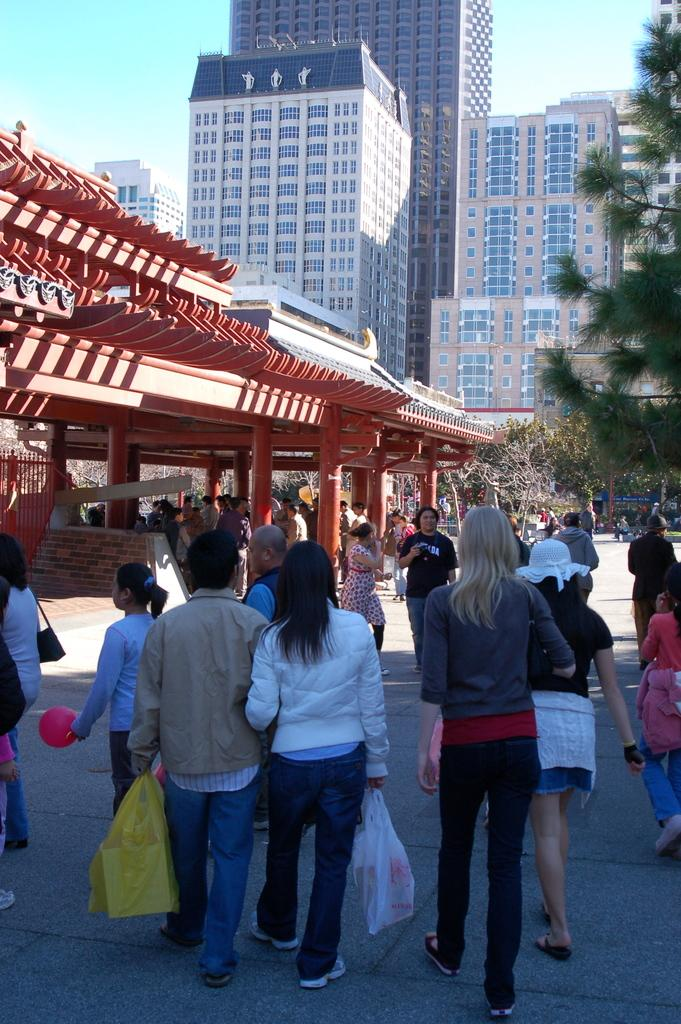What can be seen in the image? There are persons standing in the image. What type of vegetation is present in the image? There are trees in the right corner of the image. What type of structures can be seen in the background? There are buildings in the background of the image. What type of fear can be seen on the faces of the persons in the image? There is no indication of fear on the faces of the persons in the image. Can you describe the sail that is present in the image? There is no sail present in the image. 